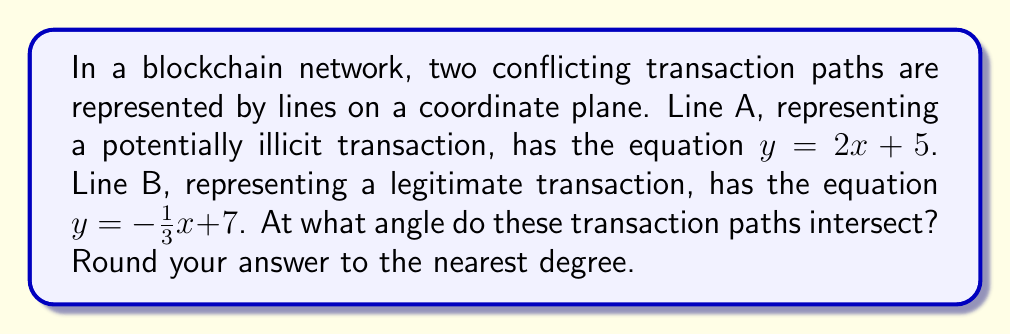Can you answer this question? To find the angle of intersection between two lines, we can follow these steps:

1. Calculate the slopes of both lines:
   Line A: $m_1 = 2$
   Line B: $m_2 = -\frac{1}{3}$

2. Use the formula for the tangent of the angle between two lines:
   $$\tan \theta = \left|\frac{m_1 - m_2}{1 + m_1m_2}\right|$$

3. Substitute the slopes into the formula:
   $$\tan \theta = \left|\frac{2 - (-\frac{1}{3})}{1 + 2(-\frac{1}{3})}\right| = \left|\frac{2 + \frac{1}{3}}{1 - \frac{2}{3}}\right| = \left|\frac{\frac{7}{3}}{\frac{1}{3}}\right| = 7$$

4. Calculate the inverse tangent (arctangent) to find the angle:
   $$\theta = \arctan(7) \approx 81.87^\circ$$

5. Round to the nearest degree:
   $$\theta \approx 82^\circ$$

[asy]
import geometry;

size(200);
defaultpen(fontsize(10pt));

pair A1 = (-2,1), A2 = (2,9);
pair B1 = (-2,7.67), B2 = (4,5.67);
pair I = intersectionpoint(A1--A2, B1--B2);

draw(A1--A2, blue+1pt, L="Line A");
draw(B1--B2, red+1pt, L="Line B");

dot(I, black);
label("Intersection", I, NE);

real angle = degrees(atan(7));
draw(arc(I, 0.5, 0, angle), green+1pt);
label(format("%.0f°", angle), I+0.7*dir(angle/2), green);
[/asy]
Answer: $82^\circ$ 